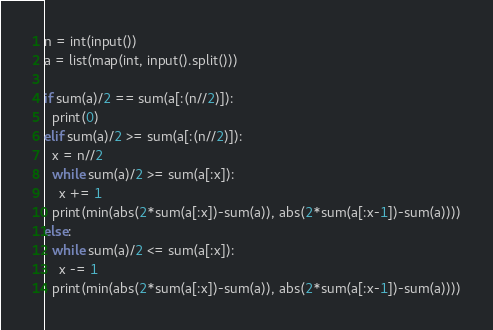<code> <loc_0><loc_0><loc_500><loc_500><_Python_>n = int(input())
a = list(map(int, input().split()))

if sum(a)/2 == sum(a[:(n//2)]):
  print(0)
elif sum(a)/2 >= sum(a[:(n//2)]):
  x = n//2
  while sum(a)/2 >= sum(a[:x]):
    x += 1  
  print(min(abs(2*sum(a[:x])-sum(a)), abs(2*sum(a[:x-1])-sum(a))))
else:
  while sum(a)/2 <= sum(a[:x]):
    x -= 1
  print(min(abs(2*sum(a[:x])-sum(a)), abs(2*sum(a[:x-1])-sum(a))))
</code> 